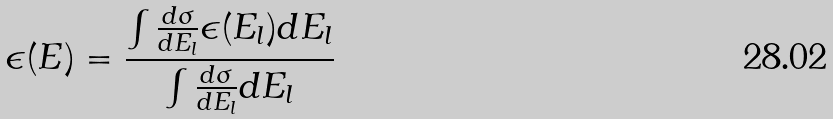<formula> <loc_0><loc_0><loc_500><loc_500>\epsilon ( E ) = \frac { \int { \frac { d \sigma } { d E _ { l } } \epsilon ( E _ { l } ) d E _ { l } } } { \int { \frac { d \sigma } { d E _ { l } } d E _ { l } } }</formula> 